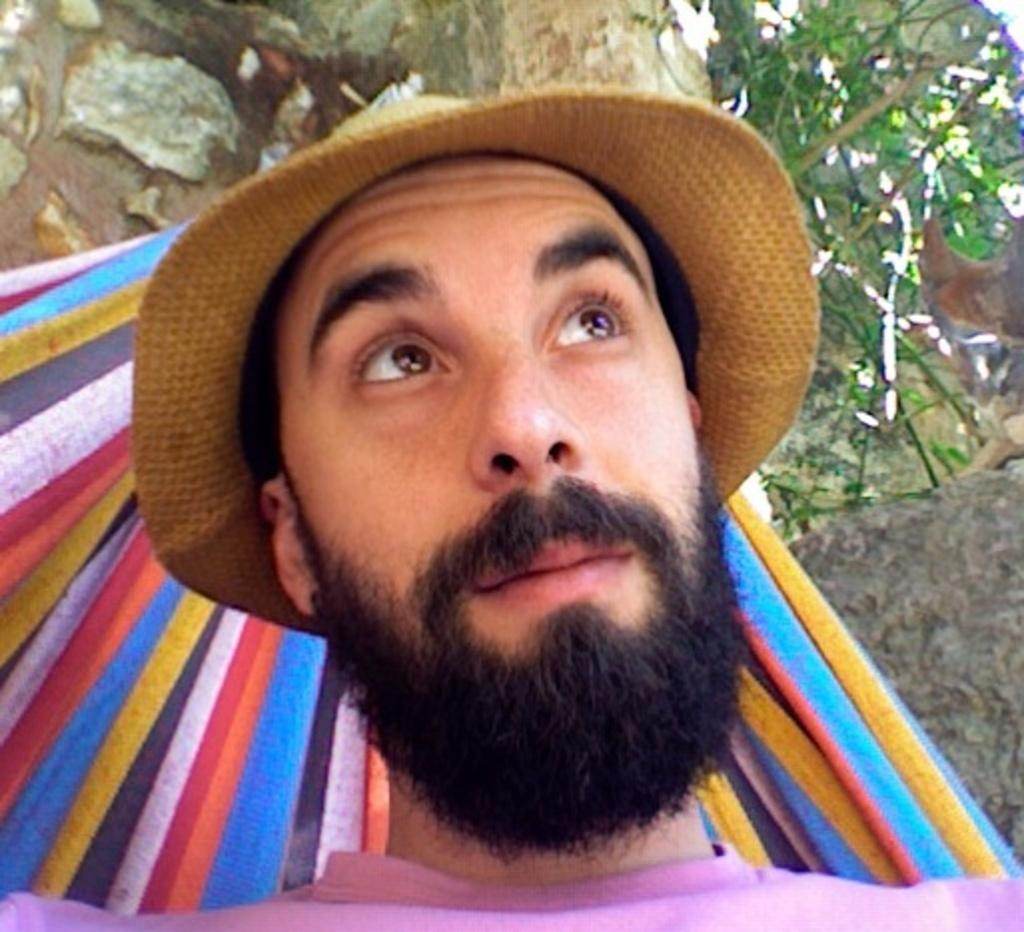Who is present in the image? There is a man in the image. What is the man wearing on his head? The man is wearing a cap. What can be seen in the background of the image? There is a cloth, a rock, and trees in the background of the image. How many children are playing with the bead in the image? There are no children or beads present in the image. What type of shoe is the man wearing in the image? The image does not show the man's shoes, so it cannot be determined what type of shoe he is wearing. 